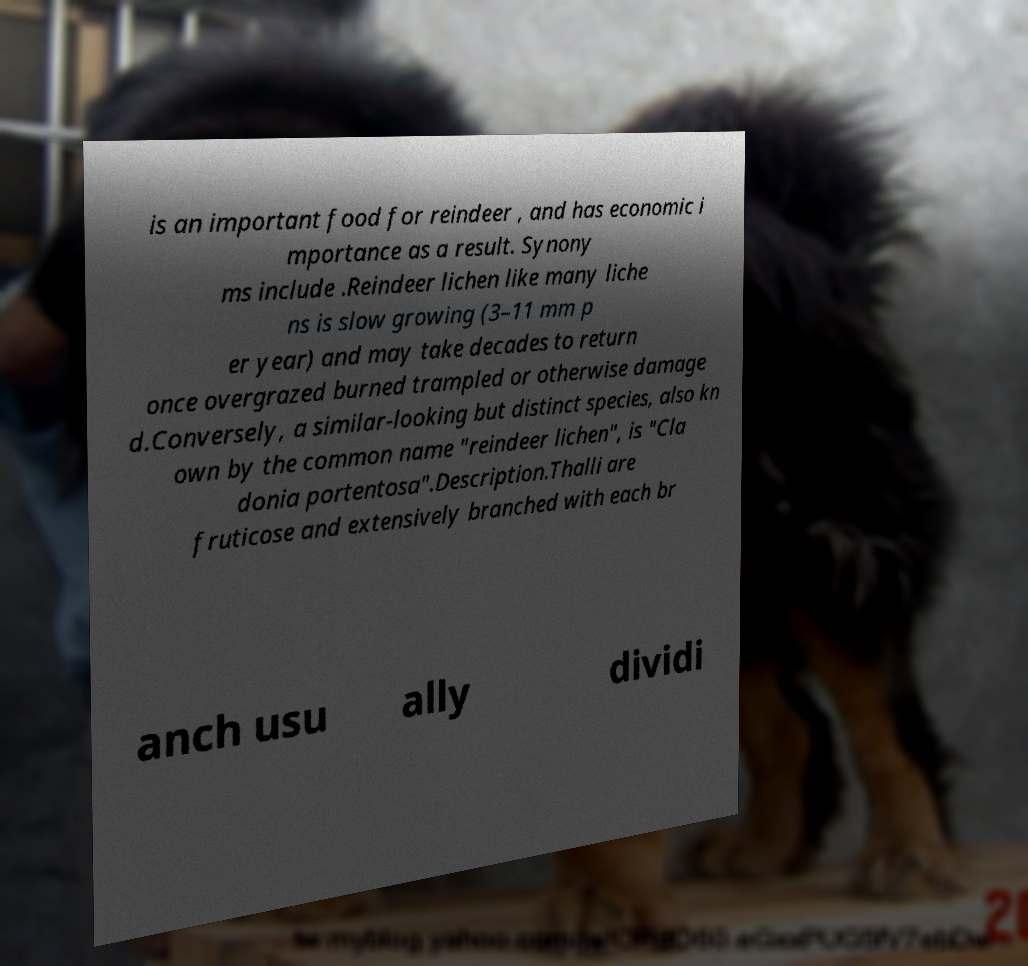I need the written content from this picture converted into text. Can you do that? is an important food for reindeer , and has economic i mportance as a result. Synony ms include .Reindeer lichen like many liche ns is slow growing (3–11 mm p er year) and may take decades to return once overgrazed burned trampled or otherwise damage d.Conversely, a similar-looking but distinct species, also kn own by the common name "reindeer lichen", is "Cla donia portentosa".Description.Thalli are fruticose and extensively branched with each br anch usu ally dividi 